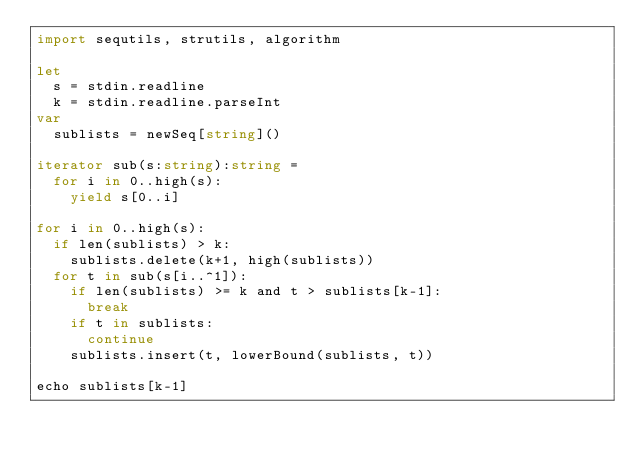Convert code to text. <code><loc_0><loc_0><loc_500><loc_500><_Nim_>import sequtils, strutils, algorithm

let
  s = stdin.readline
  k = stdin.readline.parseInt
var
  sublists = newSeq[string]()

iterator sub(s:string):string =
  for i in 0..high(s):
    yield s[0..i]

for i in 0..high(s):
  if len(sublists) > k:
    sublists.delete(k+1, high(sublists))
  for t in sub(s[i..^1]):
    if len(sublists) >= k and t > sublists[k-1]:
      break
    if t in sublists:
      continue
    sublists.insert(t, lowerBound(sublists, t))

echo sublists[k-1]
</code> 